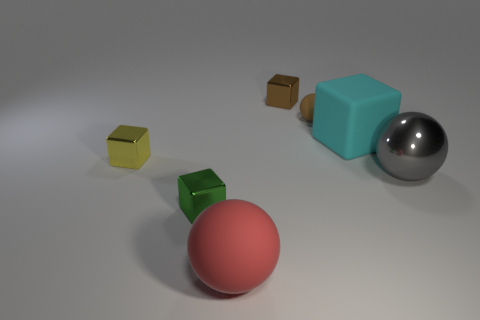There is a large sphere that is to the right of the large rubber thing that is in front of the big matte thing that is behind the tiny green thing; what is it made of? metal 